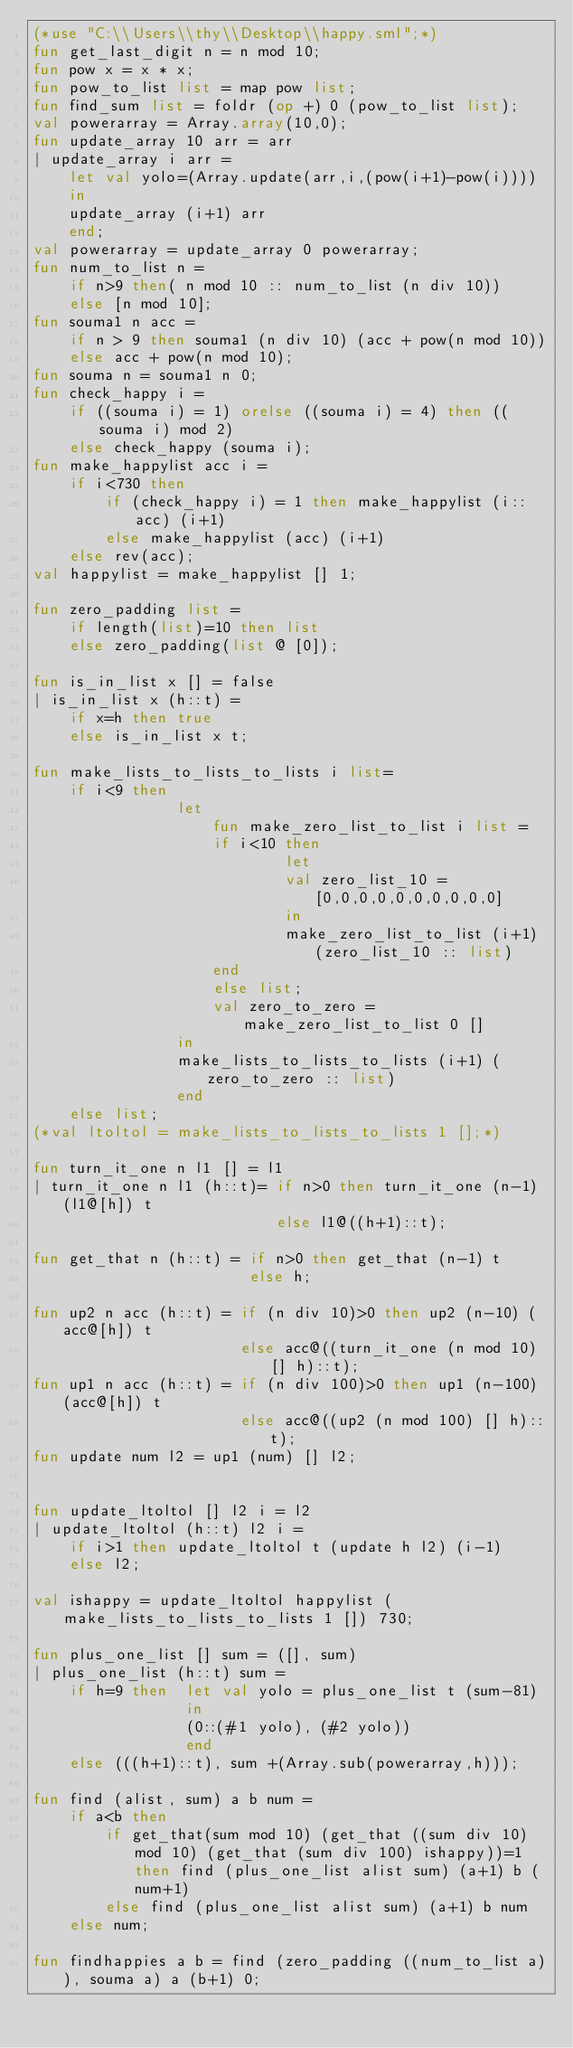<code> <loc_0><loc_0><loc_500><loc_500><_SML_>(*use "C:\\Users\\thy\\Desktop\\happy.sml";*)
fun get_last_digit n = n mod 10;
fun pow x = x * x;
fun pow_to_list list = map pow list;
fun find_sum list = foldr (op +) 0 (pow_to_list list);
val powerarray = Array.array(10,0);
fun update_array 10 arr = arr
| update_array i arr = 
	let val yolo=(Array.update(arr,i,(pow(i+1)-pow(i))))
	in
	update_array (i+1) arr
	end;
val powerarray = update_array 0 powerarray;
fun num_to_list n = 
	if n>9 then( n mod 10 :: num_to_list (n div 10))
	else [n mod 10];
fun souma1 n acc = 
	if n > 9 then souma1 (n div 10) (acc + pow(n mod 10))
	else acc + pow(n mod 10);
fun souma n = souma1 n 0;
fun check_happy i = 
	if ((souma i) = 1) orelse ((souma i) = 4) then ((souma i) mod 2)
	else check_happy (souma i);
fun make_happylist acc i =
	if i<730 then 
		if (check_happy i) = 1 then make_happylist (i::acc) (i+1)
		else make_happylist (acc) (i+1)
	else rev(acc);
val happylist = make_happylist [] 1;

fun zero_padding list =
	if length(list)=10 then list
	else zero_padding(list @ [0]);

fun is_in_list x [] = false
| is_in_list x (h::t) = 
	if x=h then true
	else is_in_list x t;
	
fun make_lists_to_lists_to_lists i list=
	if i<9 then
				let
					fun make_zero_list_to_list i list = 
					if i<10 then
							let
							val zero_list_10 = [0,0,0,0,0,0,0,0,0,0]
							in
							make_zero_list_to_list (i+1) (zero_list_10 :: list)
					end
					else list;
					val zero_to_zero = make_zero_list_to_list 0 []
				in
				make_lists_to_lists_to_lists (i+1) (zero_to_zero :: list)
				end
	else list;
(*val ltoltol = make_lists_to_lists_to_lists 1 [];*)

fun turn_it_one n l1 [] = l1
| turn_it_one n l1 (h::t)= if n>0 then turn_it_one (n-1) (l1@[h]) t
						   else l1@((h+1)::t);
						  
fun get_that n (h::t) = if n>0 then get_that (n-1) t	
						else h;
						
fun up2 n acc (h::t) = if (n div 10)>0 then up2 (n-10) (acc@[h]) t
					   else acc@((turn_it_one (n mod 10) [] h)::t);
fun up1 n acc (h::t) = if (n div 100)>0 then up1 (n-100) (acc@[h]) t
					   else acc@((up2 (n mod 100) [] h)::t);
fun update num l2 = up1 (num) [] l2;
	
						
fun update_ltoltol [] l2 i = l2
| update_ltoltol (h::t) l2 i = 
	if i>1 then update_ltoltol t (update h l2) (i-1)
	else l2;

val ishappy = update_ltoltol happylist (make_lists_to_lists_to_lists 1 []) 730;

fun plus_one_list [] sum = ([], sum)
| plus_one_list (h::t) sum =
	if h=9 then  let val yolo = plus_one_list t (sum-81)
				 in
				 (0::(#1 yolo), (#2 yolo))
				 end
	else (((h+1)::t), sum +(Array.sub(powerarray,h)));
	
fun find (alist, sum) a b num = 
	if a<b then 
		if get_that(sum mod 10) (get_that ((sum div 10) mod 10) (get_that (sum div 100) ishappy))=1 then find (plus_one_list alist sum) (a+1) b (num+1)
		else find (plus_one_list alist sum) (a+1) b num
	else num;
	
fun findhappies a b = find (zero_padding ((num_to_list a)), souma a) a (b+1) 0;</code> 